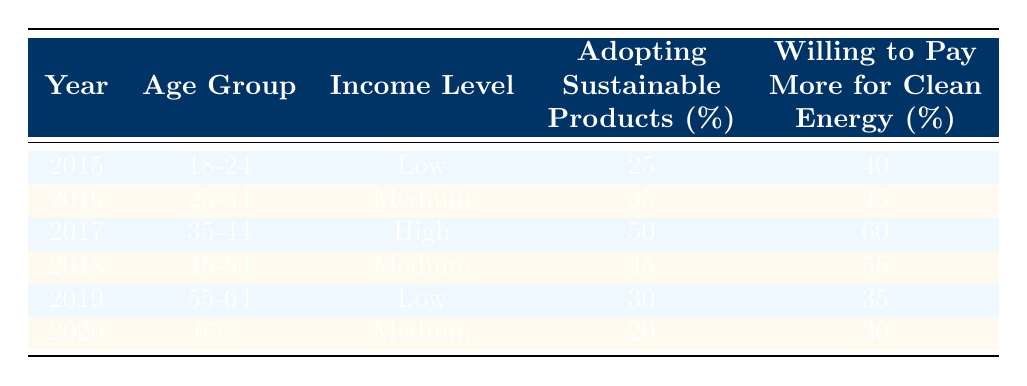What was the percentage of 18-24 age group adopting sustainable products in 2015? The table indicates that in 2015, the age group 18-24 had a percentage of 25 for adopting sustainable products.
Answer: 25 In which year did the 35-44 age group show the highest percentage willing to pay more for clean energy? According to the table, the 35-44 age group had a 60% willingness to pay more for clean energy in 2017, which is the highest compared to other years.
Answer: 2017 What is the average percentage of people willing to pay more for clean energy across all age groups over the years? To calculate the average, sum the percentages willing to pay more: 40 + 45 + 60 + 55 + 35 + 30 = 265. Then divide by the number of entries, which is 6. Therefore, the average is 265 / 6 = approximately 44.17.
Answer: 44.17 Did the percentage of the 65+ age group adopting sustainable products increase from 2015 to 2020? In 2015, the adoption percentage was not applicable for the 65+ age group since there were no data for that year. However, in 2020, it was 20%. Hence, since we cannot compare, the answer is no.
Answer: No What is the difference in the percentage of adopting sustainable products between the 25-34 age group in 2016 and the 55-64 age group in 2019? The 25-34 age group in 2016 had a percentage of 35 for adopting sustainable products, while the 55-64 age group in 2019 had a percentage of 30. The difference is 35 - 30 = 5.
Answer: 5 In which income level did the highest percentage of sustainable product adoption occur? The highest percentage of adopting sustainable products, which is 50%, is seen in the high-income level for the 35-44 age group in 2017.
Answer: High Among the demographic groups in 2019 and 2020, which age group showed the lowest percentage adopting sustainable products? In 2019, the 55-64 age group had a 30% adoption rate, and in 2020, the 65+ age group had a 20% adoption rate. Comparing these, the 65+ age group in 2020 showed the lowest percentage at 20%.
Answer: 65+ Which age group in which year had the highest overall willingness to pay more for clean energy? The 35-44 age group in 2017 had the highest overall willingness to pay more for clean energy at 60% compared to all other groups in the table.
Answer: 35-44 age group in 2017 